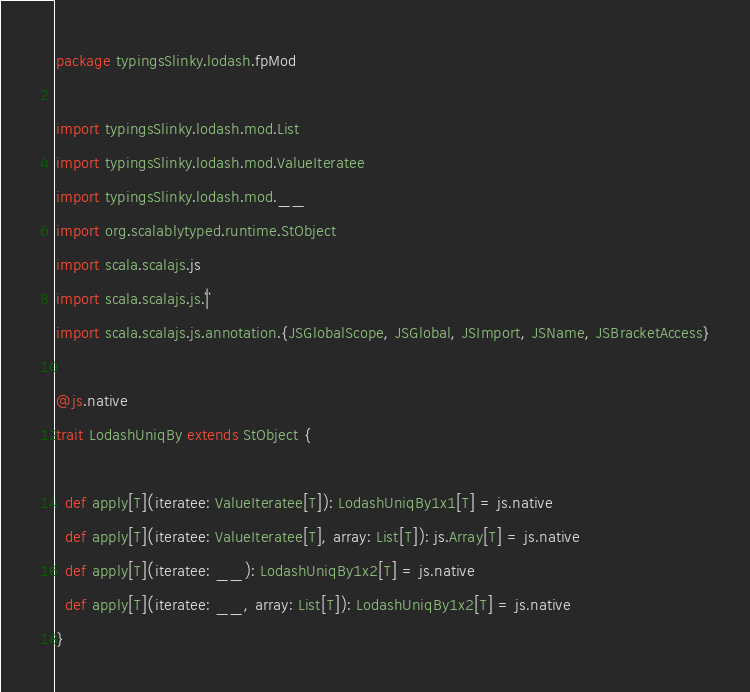Convert code to text. <code><loc_0><loc_0><loc_500><loc_500><_Scala_>package typingsSlinky.lodash.fpMod

import typingsSlinky.lodash.mod.List
import typingsSlinky.lodash.mod.ValueIteratee
import typingsSlinky.lodash.mod.__
import org.scalablytyped.runtime.StObject
import scala.scalajs.js
import scala.scalajs.js.`|`
import scala.scalajs.js.annotation.{JSGlobalScope, JSGlobal, JSImport, JSName, JSBracketAccess}

@js.native
trait LodashUniqBy extends StObject {
  
  def apply[T](iteratee: ValueIteratee[T]): LodashUniqBy1x1[T] = js.native
  def apply[T](iteratee: ValueIteratee[T], array: List[T]): js.Array[T] = js.native
  def apply[T](iteratee: __): LodashUniqBy1x2[T] = js.native
  def apply[T](iteratee: __, array: List[T]): LodashUniqBy1x2[T] = js.native
}
</code> 